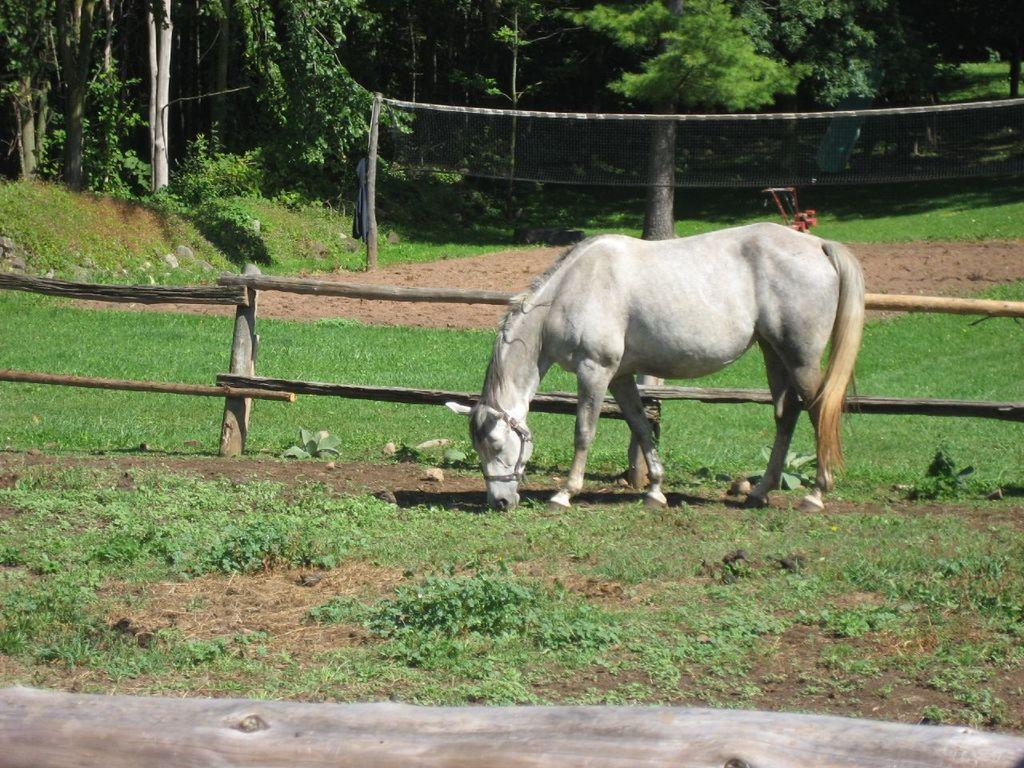What animal can be seen in the image? There is a horse in the image. What type of vegetation is present in the image? There is grass, plants, and trees in the image. What is the barrier made of in the image? There is a wooden fence in the image. What type of muscle can be seen flexing on the horse's back in the image? There is no muscle visible on the horse's back in the image. What mountain range is visible in the background of the image? There is no mountain range visible in the image; it features a horse, grass, plants, trees, and a wooden fence. 